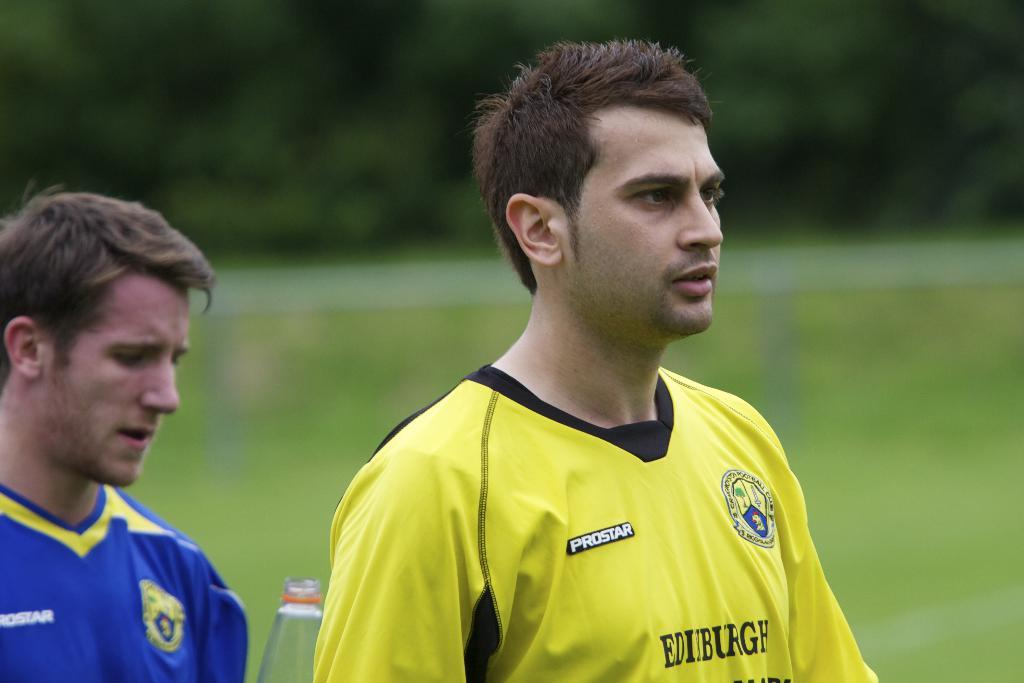<image>
Describe the image concisely. Two men wearing a yellow and black shirt and the other man has on a blue and yellow shirt with the word Ediburgh written on front. 